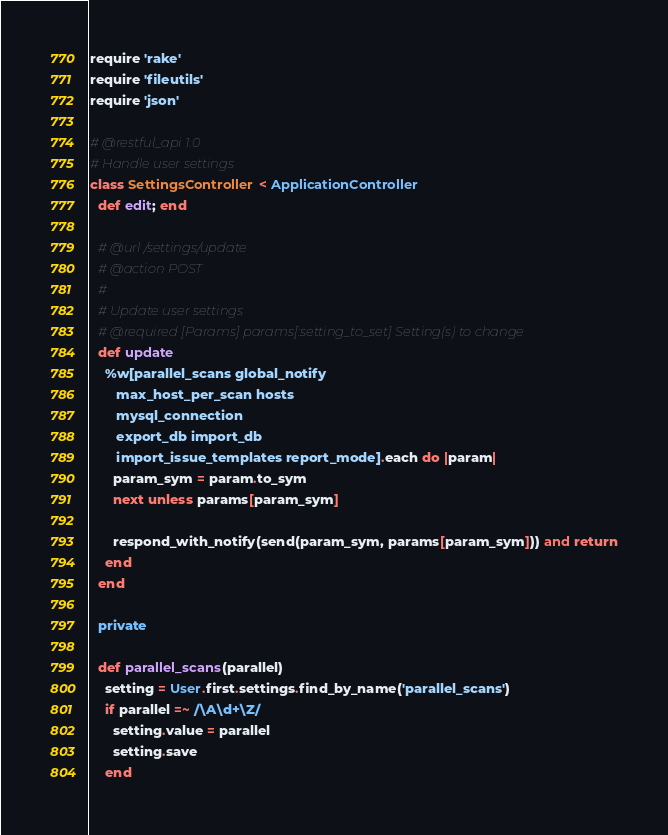<code> <loc_0><loc_0><loc_500><loc_500><_Ruby_>require 'rake'
require 'fileutils'
require 'json'

# @restful_api 1.0
# Handle user settings
class SettingsController < ApplicationController
  def edit; end

  # @url /settings/update
  # @action POST
  #
  # Update user settings
  # @required [Params] params[:setting_to_set] Setting(s) to change
  def update
    %w[parallel_scans global_notify
       max_host_per_scan hosts
       mysql_connection
       export_db import_db
       import_issue_templates report_mode].each do |param|
      param_sym = param.to_sym
      next unless params[param_sym]

      respond_with_notify(send(param_sym, params[param_sym])) and return
    end
  end

  private

  def parallel_scans(parallel)
    setting = User.first.settings.find_by_name('parallel_scans')
    if parallel =~ /\A\d+\Z/
      setting.value = parallel
      setting.save
    end</code> 